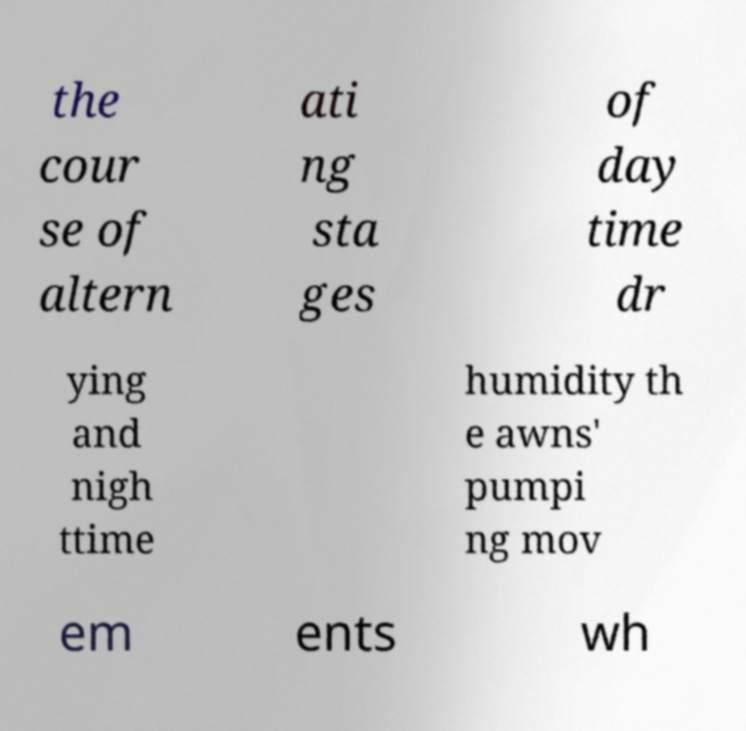Can you accurately transcribe the text from the provided image for me? the cour se of altern ati ng sta ges of day time dr ying and nigh ttime humidity th e awns' pumpi ng mov em ents wh 